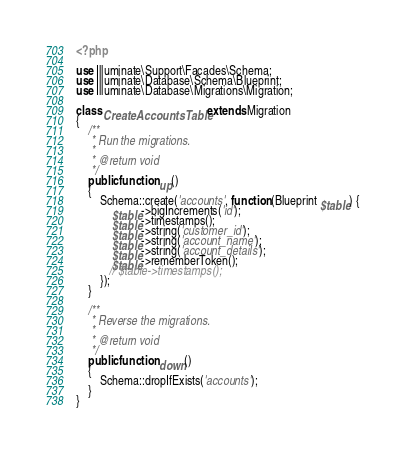Convert code to text. <code><loc_0><loc_0><loc_500><loc_500><_PHP_><?php

use Illuminate\Support\Facades\Schema;
use Illuminate\Database\Schema\Blueprint;
use Illuminate\Database\Migrations\Migration;

class CreateAccountsTable extends Migration
{
    /**
     * Run the migrations.
     *
     * @return void
     */
    public function up()
    {
        Schema::create('accounts', function (Blueprint $table) {
            $table->bigIncrements('id');
            $table->timestamps();
            $table->string('customer_id');
            $table->string('account_name');
            $table->string('account_details');
            $table->rememberToken();
           // $table->timestamps();
        });
    }

    /**
     * Reverse the migrations.
     *
     * @return void
     */
    public function down()
    {
        Schema::dropIfExists('accounts');
    }
}
</code> 